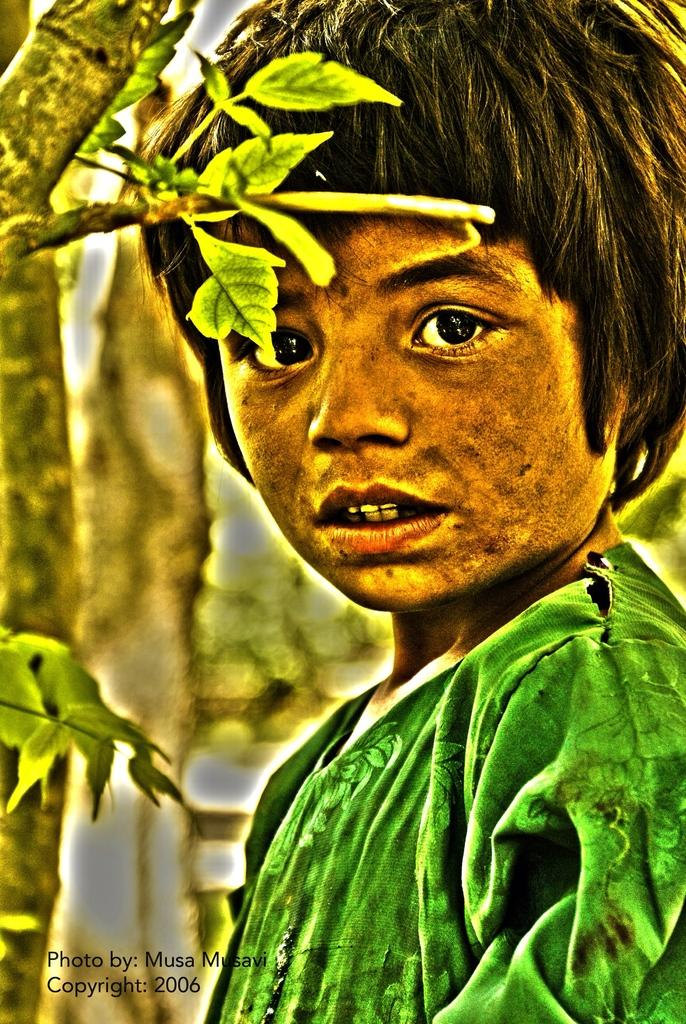Who or what is present in the image? There is a person in the image. What can be seen in the background behind the person? There are trees behind the person. Is there any additional information about the image itself? The image has a watermark. What type of game is being played in the image? There is no game being played in the image; it features a person and trees in the background. Can you describe the vase that is present in the image? There is no vase present in the image. 